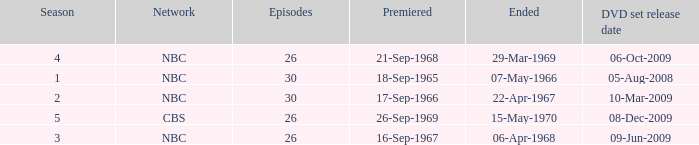When dis cbs release the DVD set? 08-Dec-2009. 